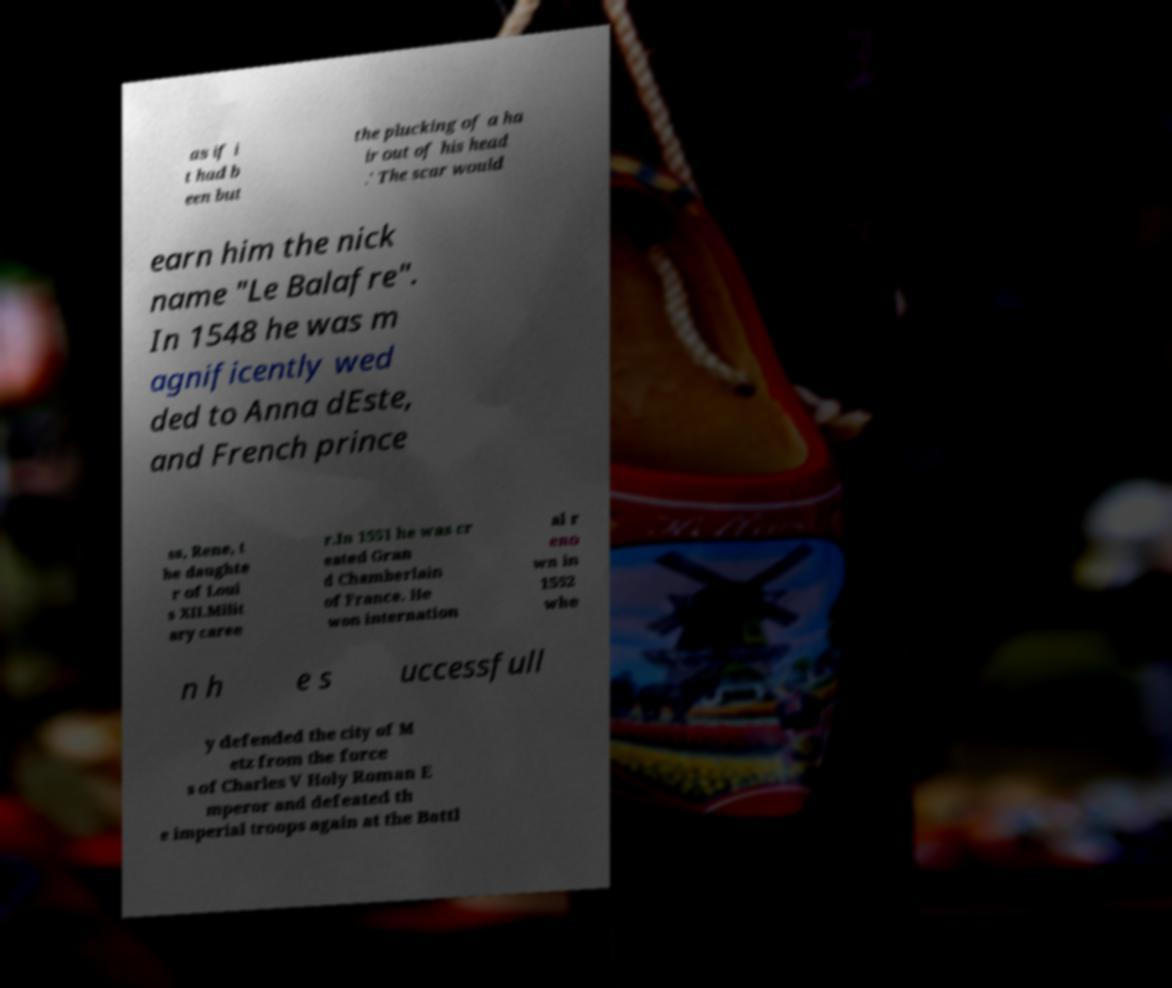Can you accurately transcribe the text from the provided image for me? as if i t had b een but the plucking of a ha ir out of his head .' The scar would earn him the nick name "Le Balafre". In 1548 he was m agnificently wed ded to Anna dEste, and French prince ss, Rene, t he daughte r of Loui s XII.Milit ary caree r.In 1551 he was cr eated Gran d Chamberlain of France. He won internation al r eno wn in 1552 whe n h e s uccessfull y defended the city of M etz from the force s of Charles V Holy Roman E mperor and defeated th e imperial troops again at the Battl 